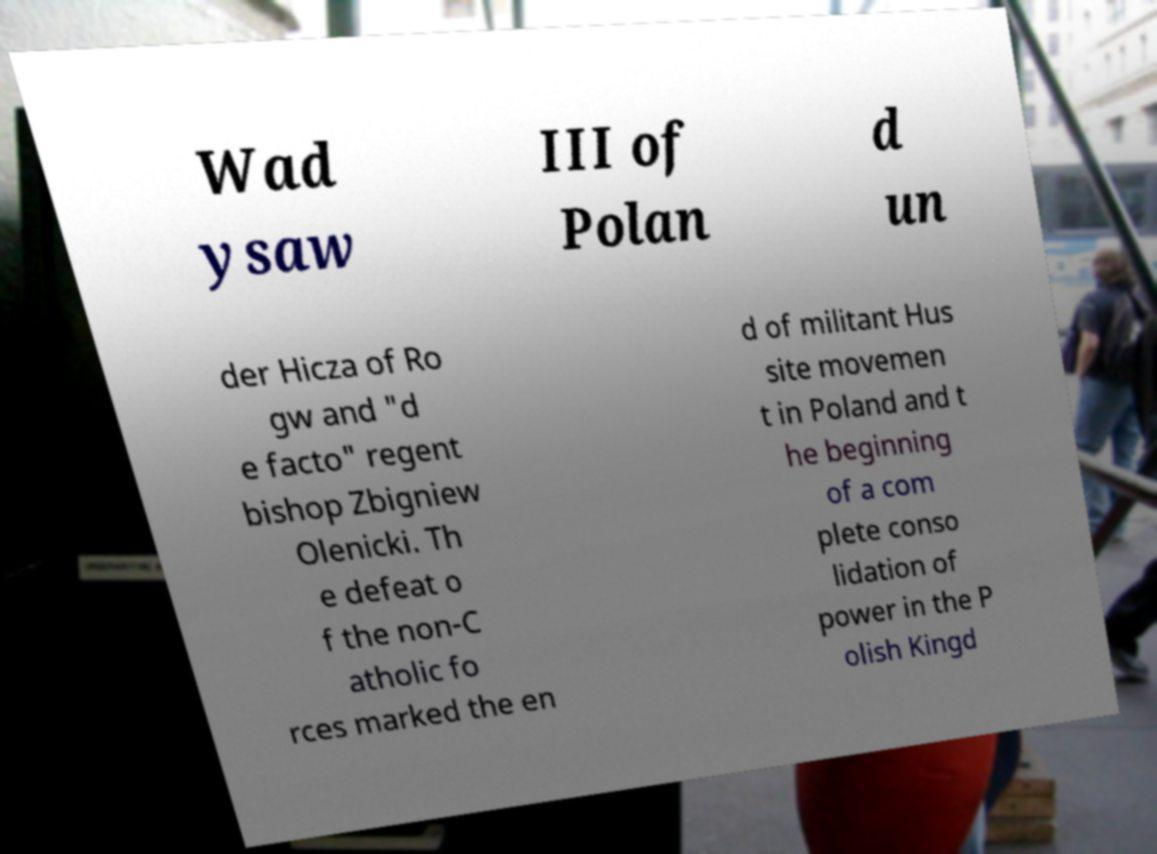Could you assist in decoding the text presented in this image and type it out clearly? Wad ysaw III of Polan d un der Hicza of Ro gw and "d e facto" regent bishop Zbigniew Olenicki. Th e defeat o f the non-C atholic fo rces marked the en d of militant Hus site movemen t in Poland and t he beginning of a com plete conso lidation of power in the P olish Kingd 